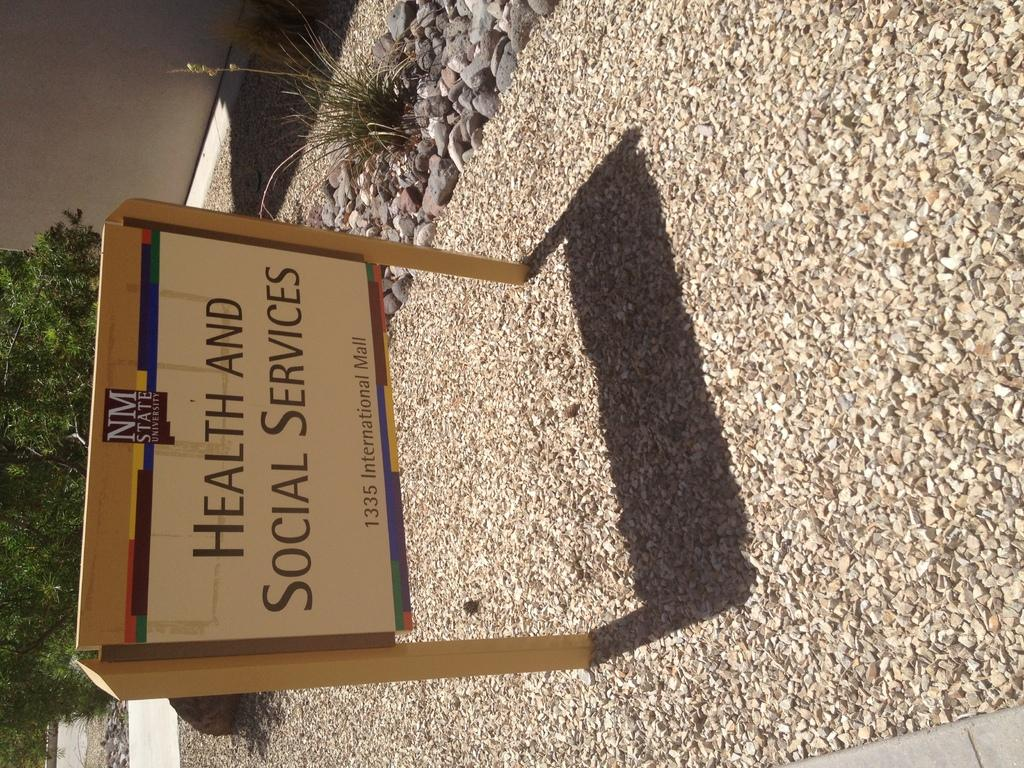What is on the board that is visible in the image? There is text on the board in the image. How are the stones related to the board in the image? The board is on stones in the image. What type of vegetation is present in the image? There is a plant in the image, and trees are present on the ground beside the wall. What is the background of the image? There is a wall in the image, and trees are present on the ground beside it. What type of chain can be seen hanging from the faucet in the image? There is no faucet or chain present in the image. 